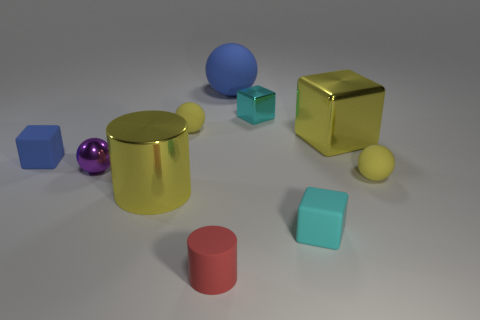Subtract 1 blocks. How many blocks are left? 3 Subtract all cubes. How many objects are left? 6 Subtract all big blue rubber objects. Subtract all large blue things. How many objects are left? 8 Add 8 metal spheres. How many metal spheres are left? 9 Add 5 small cyan cubes. How many small cyan cubes exist? 7 Subtract 0 brown cubes. How many objects are left? 10 